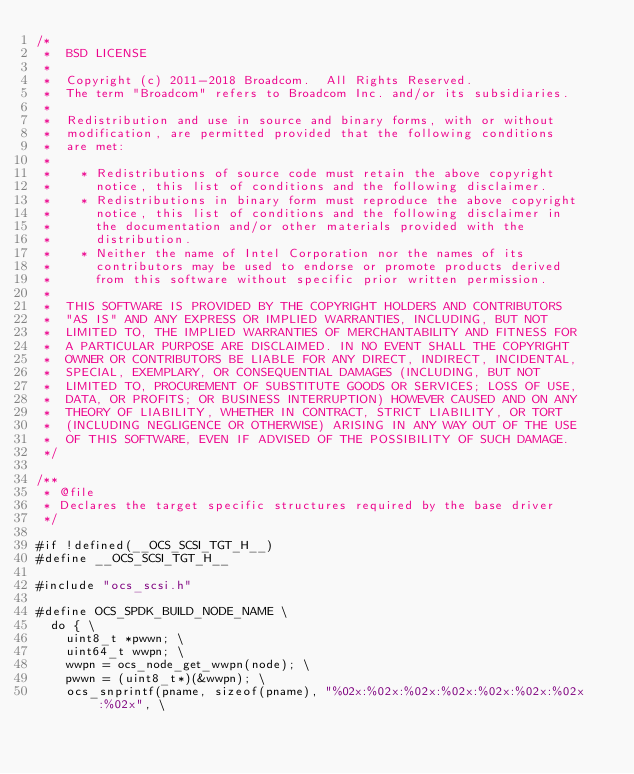Convert code to text. <code><loc_0><loc_0><loc_500><loc_500><_C_>/*
 *  BSD LICENSE
 *
 *  Copyright (c) 2011-2018 Broadcom.  All Rights Reserved.
 *  The term "Broadcom" refers to Broadcom Inc. and/or its subsidiaries.
 *
 *  Redistribution and use in source and binary forms, with or without
 *  modification, are permitted provided that the following conditions
 *  are met:
 *
 *    * Redistributions of source code must retain the above copyright
 *      notice, this list of conditions and the following disclaimer.
 *    * Redistributions in binary form must reproduce the above copyright
 *      notice, this list of conditions and the following disclaimer in
 *      the documentation and/or other materials provided with the
 *      distribution.
 *    * Neither the name of Intel Corporation nor the names of its
 *      contributors may be used to endorse or promote products derived
 *      from this software without specific prior written permission.
 *
 *  THIS SOFTWARE IS PROVIDED BY THE COPYRIGHT HOLDERS AND CONTRIBUTORS
 *  "AS IS" AND ANY EXPRESS OR IMPLIED WARRANTIES, INCLUDING, BUT NOT
 *  LIMITED TO, THE IMPLIED WARRANTIES OF MERCHANTABILITY AND FITNESS FOR
 *  A PARTICULAR PURPOSE ARE DISCLAIMED. IN NO EVENT SHALL THE COPYRIGHT
 *  OWNER OR CONTRIBUTORS BE LIABLE FOR ANY DIRECT, INDIRECT, INCIDENTAL,
 *  SPECIAL, EXEMPLARY, OR CONSEQUENTIAL DAMAGES (INCLUDING, BUT NOT
 *  LIMITED TO, PROCUREMENT OF SUBSTITUTE GOODS OR SERVICES; LOSS OF USE,
 *  DATA, OR PROFITS; OR BUSINESS INTERRUPTION) HOWEVER CAUSED AND ON ANY
 *  THEORY OF LIABILITY, WHETHER IN CONTRACT, STRICT LIABILITY, OR TORT
 *  (INCLUDING NEGLIGENCE OR OTHERWISE) ARISING IN ANY WAY OUT OF THE USE
 *  OF THIS SOFTWARE, EVEN IF ADVISED OF THE POSSIBILITY OF SUCH DAMAGE.
 */

/**
 * @file
 * Declares the target specific structures required by the base driver
 */

#if !defined(__OCS_SCSI_TGT_H__)
#define __OCS_SCSI_TGT_H__

#include "ocs_scsi.h"

#define OCS_SPDK_BUILD_NODE_NAME \
	do { \
		uint8_t *pwwn; \
		uint64_t wwpn; \
		wwpn = ocs_node_get_wwpn(node); \
		pwwn = (uint8_t*)(&wwpn); \
		ocs_snprintf(pname, sizeof(pname), "%02x:%02x:%02x:%02x:%02x:%02x:%02x:%02x", \</code> 